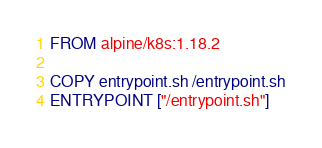Convert code to text. <code><loc_0><loc_0><loc_500><loc_500><_Dockerfile_>FROM alpine/k8s:1.18.2

COPY entrypoint.sh /entrypoint.sh
ENTRYPOINT ["/entrypoint.sh"]
</code> 